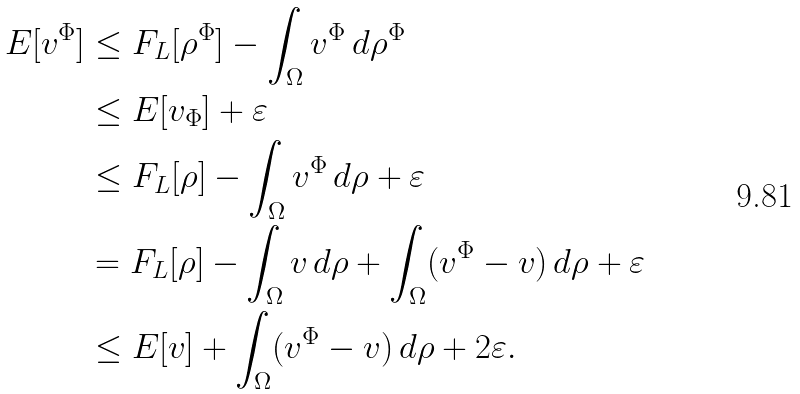Convert formula to latex. <formula><loc_0><loc_0><loc_500><loc_500>E [ v ^ { \Phi } ] & \leq F _ { L } [ \rho ^ { \Phi } ] - \int _ { \Omega } v ^ { \Phi } \, d \rho ^ { \Phi } \\ & \leq E [ v _ { \Phi } ] + \varepsilon \\ & \leq F _ { L } [ \rho ] - \int _ { \Omega } v ^ { \Phi } \, d \rho + \varepsilon \\ & = F _ { L } [ \rho ] - \int _ { \Omega } v \, d \rho + \int _ { \Omega } ( v ^ { \Phi } - v ) \, d \rho + \varepsilon \\ & \leq E [ v ] + \int _ { \Omega } ( v ^ { \Phi } - v ) \, d \rho + 2 \varepsilon .</formula> 